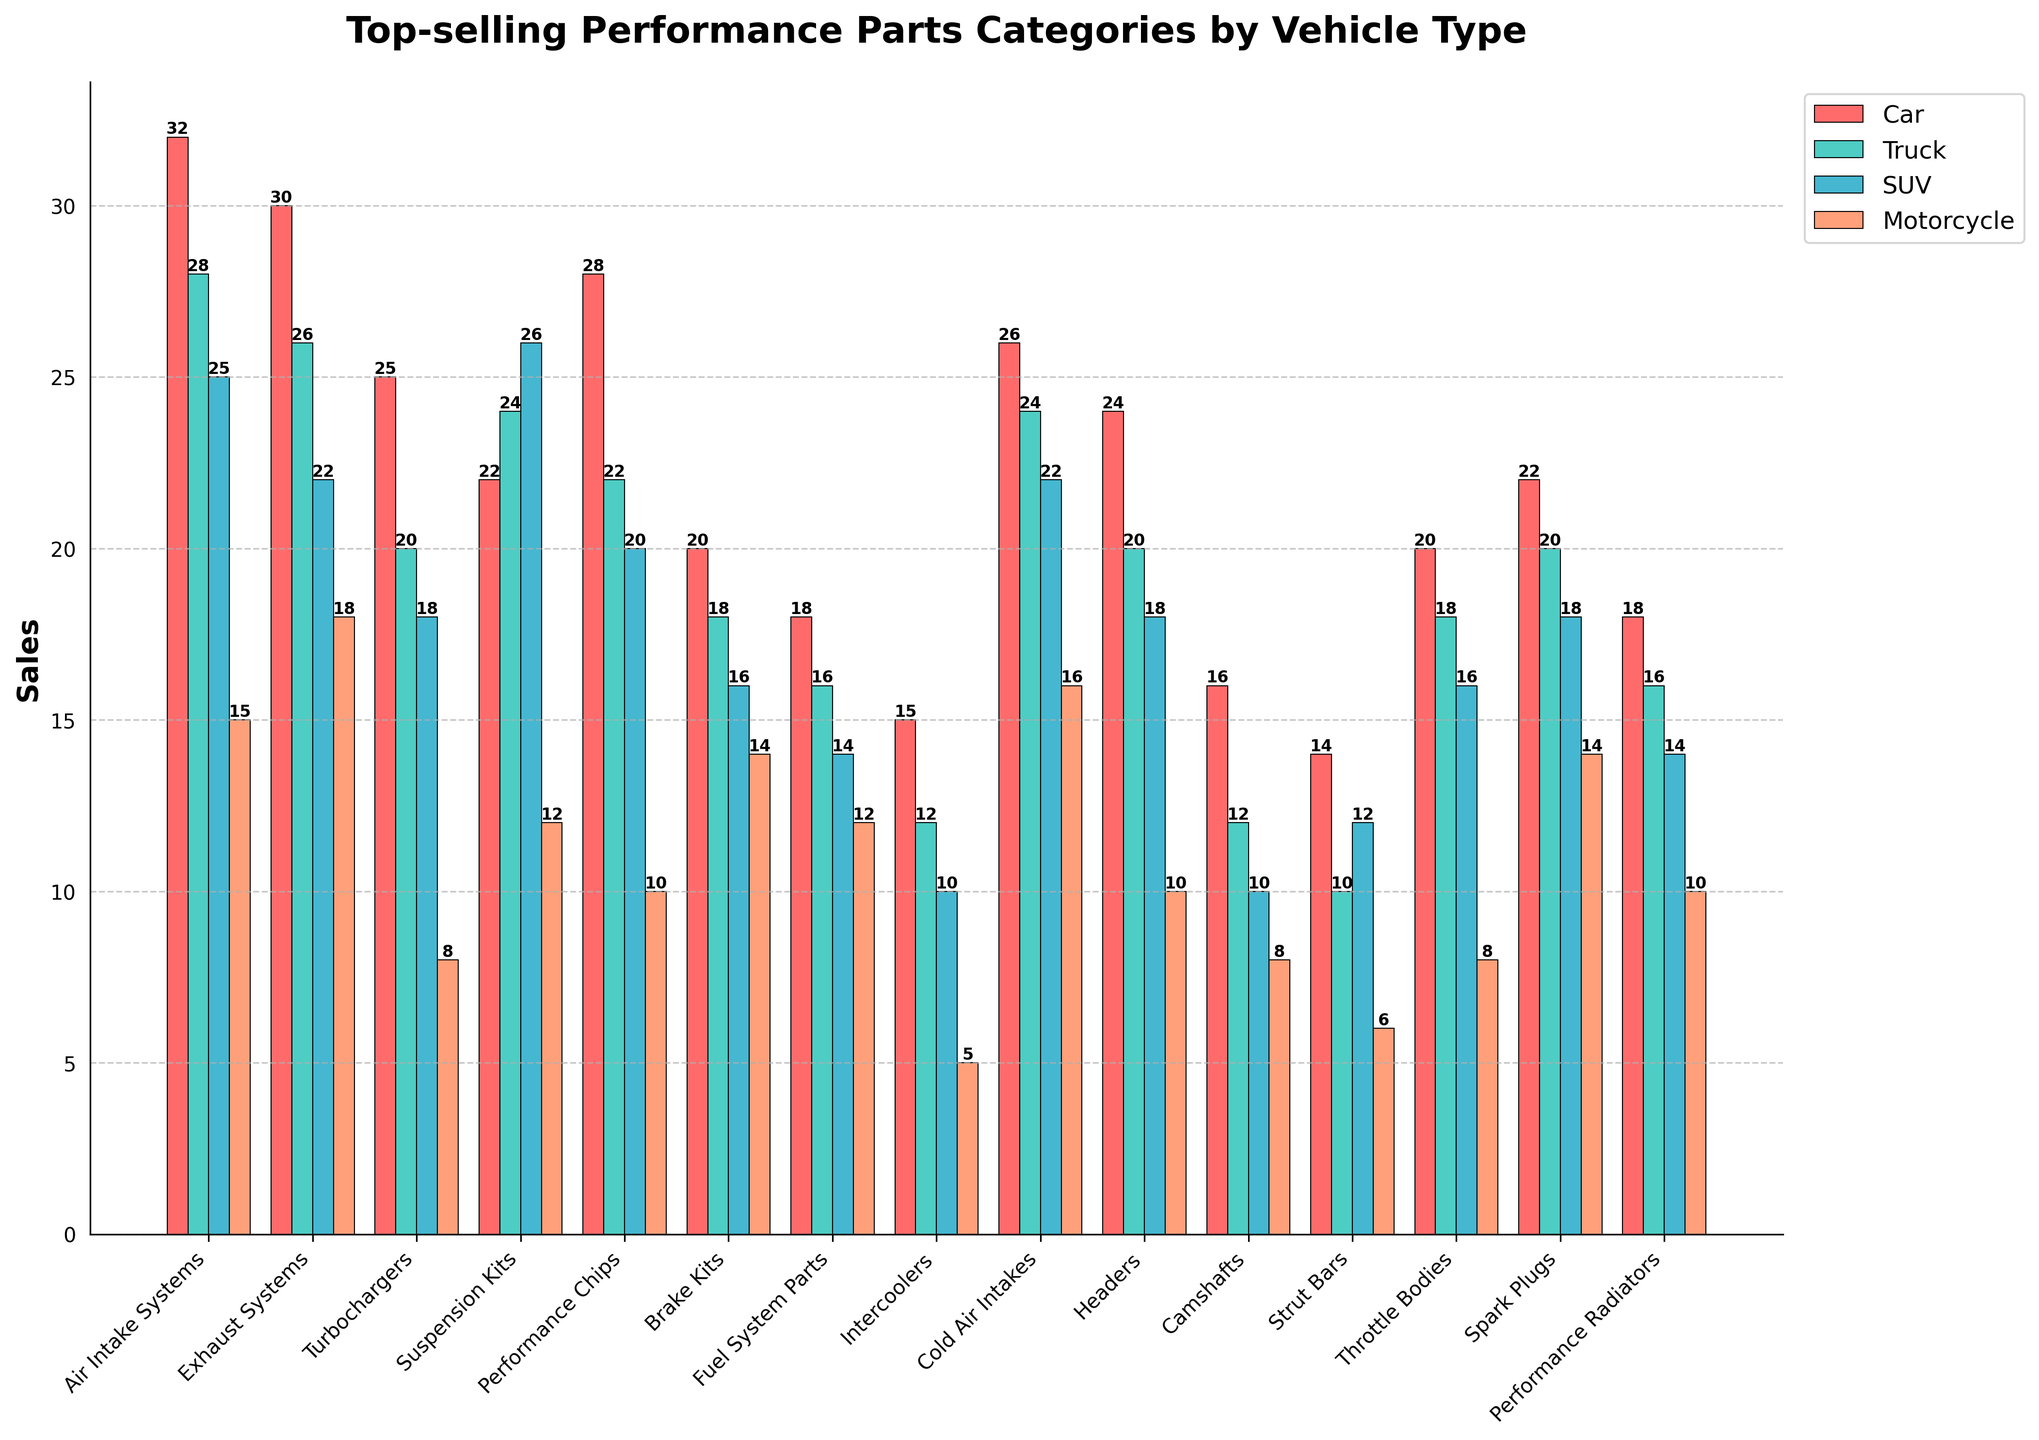Which vehicle type has the highest sales for Air Intake Systems? The highest bar for Air Intake Systems is the red bar representing car sales, which is at 32.
Answer: Car Which performance part category sees the highest sales for motorcycles? The motorcycle category with the highest bar is Exhaust Systems, with a value of 18.
Answer: Exhaust Systems How many more Turbochargers are sold for cars than for motorcycles? The Turbochargers sold for cars are 25, and for motorcycles, it is 8. The difference between them is 25 - 8 = 17.
Answer: 17 What is the average number of Cold Air Intakes sold across all vehicle types? The sales for Cold Air Intakes are 26 (Car), 24 (Truck), 22 (SUV), and 16 (Motorcycle). The average is (26 + 24 + 22 + 16) / 4 = 88 / 4 = 22.
Answer: 22 Which category has the smallest sum of performance parts sold across all vehicle types? The smallest total is for Intercoolers: 15 (Car) + 12 (Truck) + 10 (SUV) + 5 (Motorcycle) = 42.
Answer: Intercoolers For which vehicle type are Brake Kits more popular than Throttle Bodies? The sales of Brake Kits are 20 (Car), 18 (Truck), 16 (SUV), and 14 (Motorcycle). The sales of Throttle Bodies are 20 (Car), 18 (Truck), 16 (SUV), and 8 (Motorcycle). Hence, Brake Kits are more popular for Motorcycles where the sales are 14, while Throttle Bodies have 8.
Answer: Motorcycle Which performance part category has the highest sales variance among vehicle types? The variance for each part can be found by calculating the spread of each category. Suspension Kits for instance: Car 22, Truck 24, SUV 26, Motorcycle 12 spread is quite large. However, exact variance calculations involve each deviation squared, summed, and divided by the count, which for Suspension Kits is high due to its spread.
Answer: Suspension Kits Which vehicle type shows the least variation in sales across all performance parts categories? Calculating exact variance involves going through all categories for each type and checking standard deviation, but visually noticing that Truck categories do not oscillate in a wide range seems correct.
Answer: Truck If you consider Air Intake Systems and Exhaust Systems together, which category shows higher total sales for cars? Air Intake Systems for Cars is 32, Exhaust Systems for Cars is 30. Together, it's 62 (Air Intake Systems) vs just considering Exhaust Systems, which is 30.
Answer: Air Intake Systems How many more performance parts are sold for cars compared to trucks in the Exhaust Systems category? Sales for cars in Exhaust Systems is 30, and for trucks, it is 26. The difference is 30 - 26 = 4.
Answer: 4 